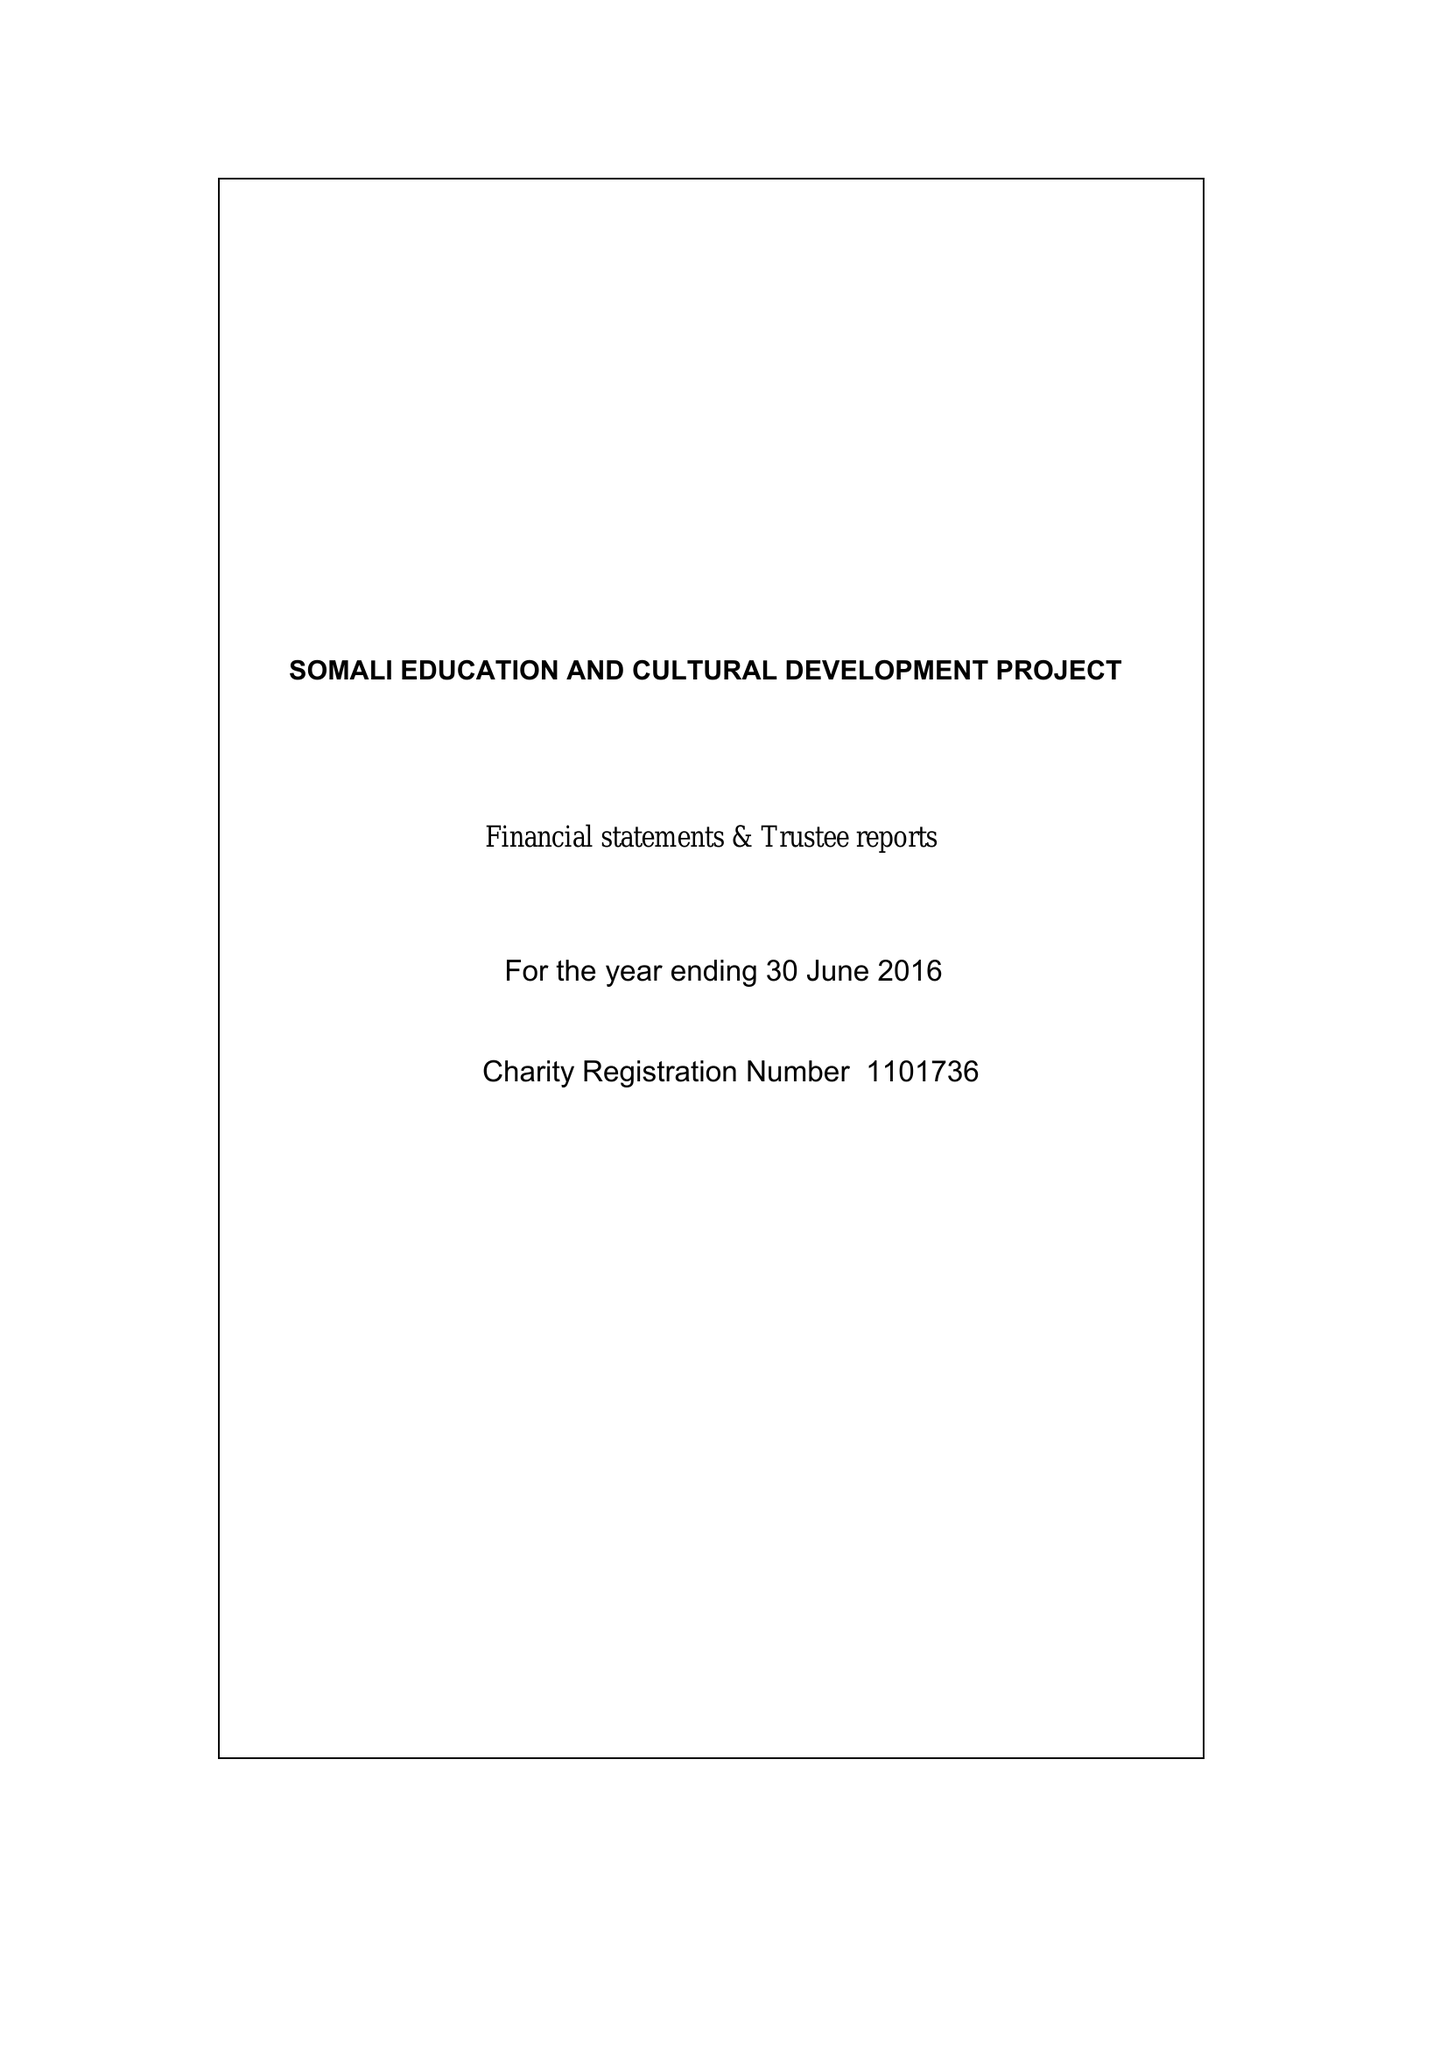What is the value for the address__post_town?
Answer the question using a single word or phrase. LONDON 